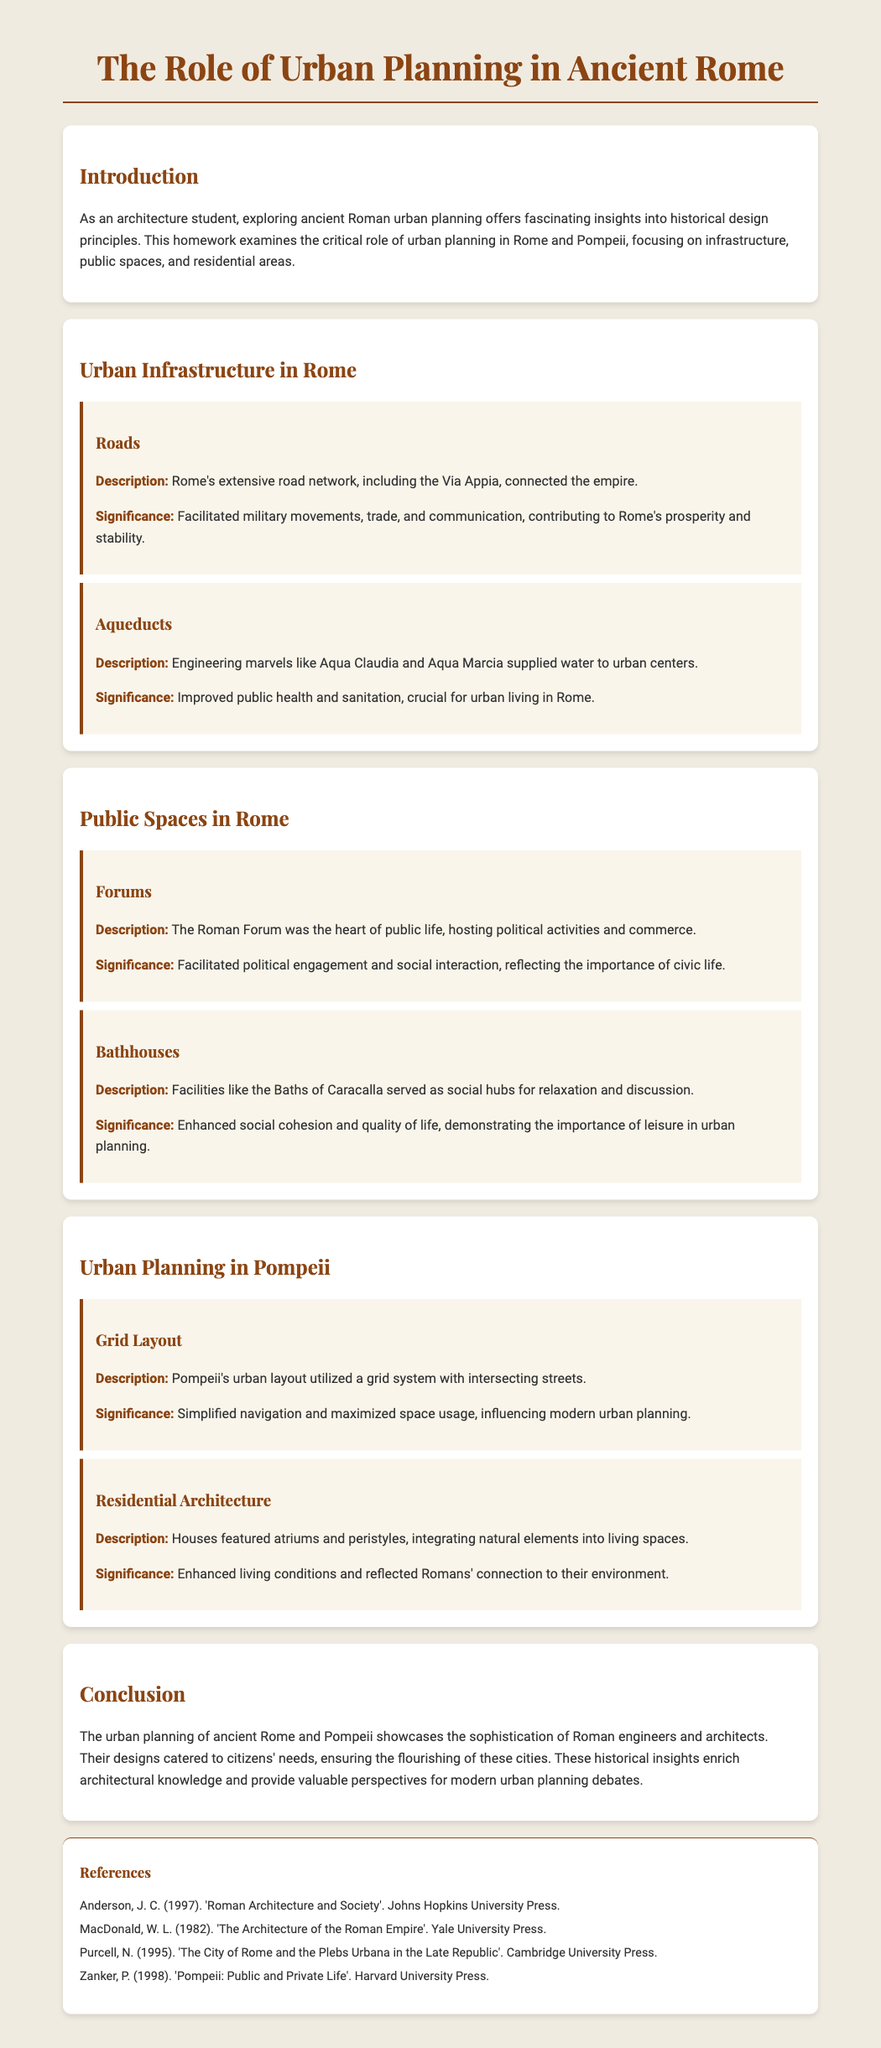What is the main subject of the homework? The homework focuses on examining the critical role of urban planning in Rome and Pompeii.
Answer: Urban planning in Rome and Pompeii Which road is mentioned as part of Rome's infrastructure? The document highlights the Via Appia in the context of Rome's extensive road network.
Answer: Via Appia What was the significance of aqueducts in ancient Rome? The document states that aqueducts improved public health and sanitation, crucial for urban living.
Answer: Improved public health and sanitation What is described as the heart of public life in Rome? The document refers to the Roman Forum as the center of political activities and commerce.
Answer: Roman Forum What urban layout system did Pompeii utilize? The document describes Pompeii's urban layout as a grid system with intersecting streets.
Answer: Grid system What architectural feature is emphasized in Pompeii's residential architecture? The document states that houses in Pompeii featured atriums and peristyles.
Answer: Atriums and peristyles Which facilities served as social hubs in ancient Rome? The document mentions the Baths of Caracalla as facilities that enhanced social life.
Answer: Baths of Caracalla What reflects the significance of civic life in ancient Rome? The document indicates that forums facilitated political engagement and social interaction.
Answer: Forums 